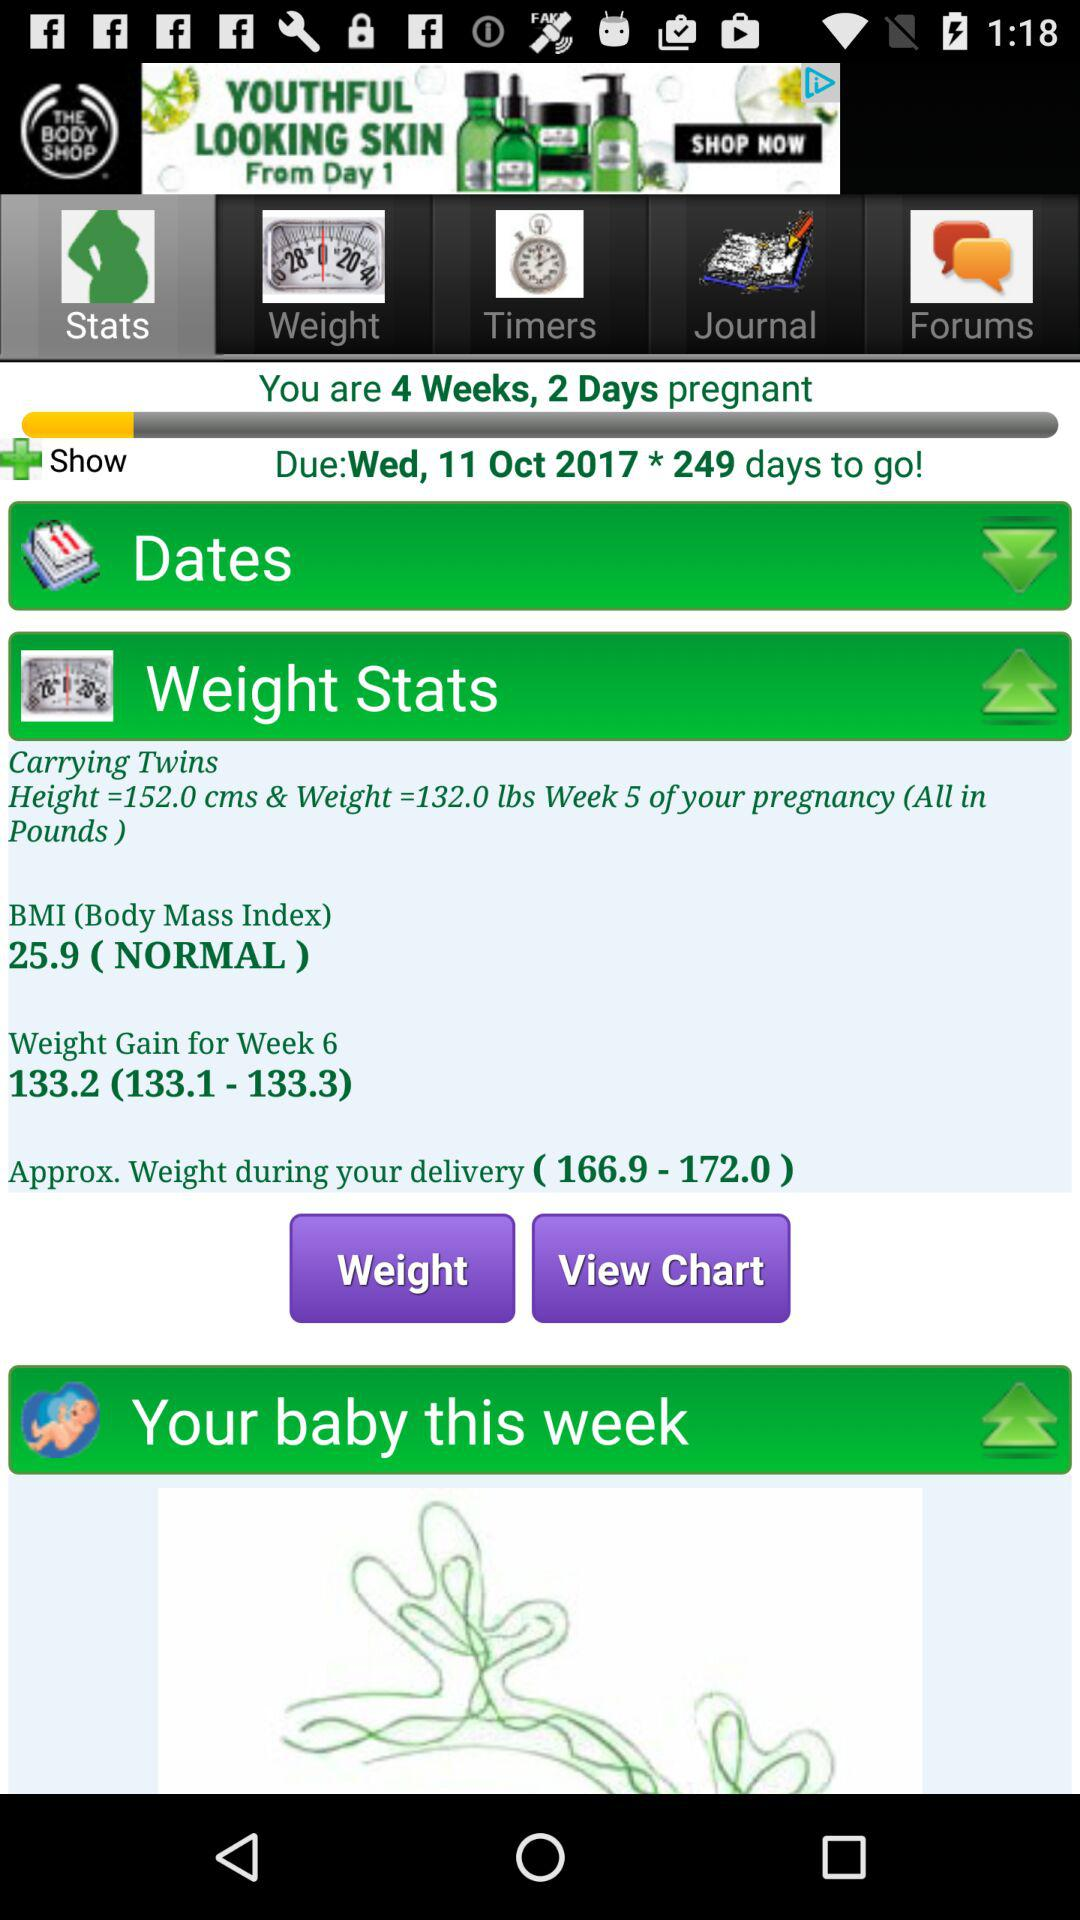What is the given height and weight of the twins? The given height is 152 cms and the weight is 132 lbs. 